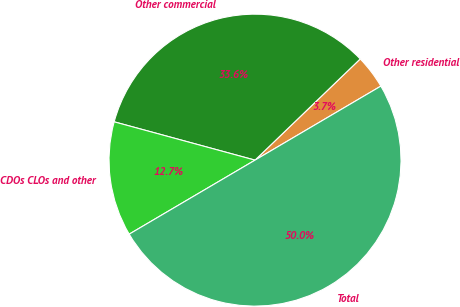<chart> <loc_0><loc_0><loc_500><loc_500><pie_chart><fcel>Other residential<fcel>Other commercial<fcel>CDOs CLOs and other<fcel>Total<nl><fcel>3.73%<fcel>33.58%<fcel>12.69%<fcel>50.0%<nl></chart> 